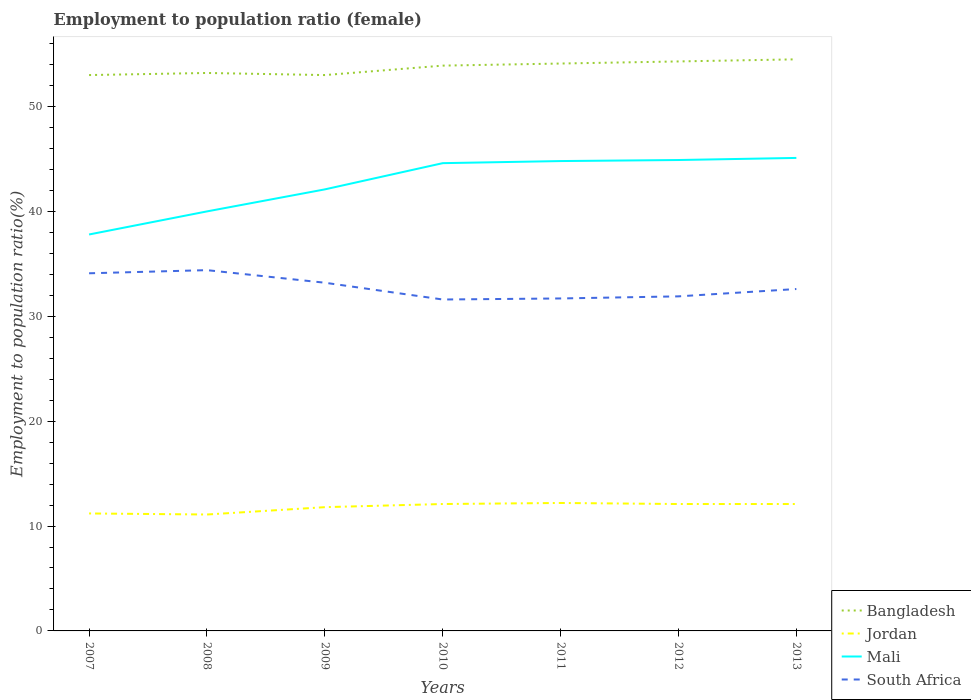Is the number of lines equal to the number of legend labels?
Provide a short and direct response. Yes. Across all years, what is the maximum employment to population ratio in Jordan?
Offer a very short reply. 11.1. What is the total employment to population ratio in Jordan in the graph?
Provide a short and direct response. -0.4. What is the difference between the highest and the second highest employment to population ratio in Jordan?
Your answer should be compact. 1.1. What is the difference between the highest and the lowest employment to population ratio in South Africa?
Offer a very short reply. 3. Are the values on the major ticks of Y-axis written in scientific E-notation?
Offer a very short reply. No. Does the graph contain any zero values?
Provide a succinct answer. No. Does the graph contain grids?
Provide a succinct answer. No. How many legend labels are there?
Give a very brief answer. 4. What is the title of the graph?
Provide a succinct answer. Employment to population ratio (female). Does "St. Vincent and the Grenadines" appear as one of the legend labels in the graph?
Make the answer very short. No. What is the label or title of the X-axis?
Give a very brief answer. Years. What is the Employment to population ratio(%) in Bangladesh in 2007?
Your response must be concise. 53. What is the Employment to population ratio(%) of Jordan in 2007?
Offer a terse response. 11.2. What is the Employment to population ratio(%) in Mali in 2007?
Provide a short and direct response. 37.8. What is the Employment to population ratio(%) in South Africa in 2007?
Your response must be concise. 34.1. What is the Employment to population ratio(%) of Bangladesh in 2008?
Offer a terse response. 53.2. What is the Employment to population ratio(%) in Jordan in 2008?
Keep it short and to the point. 11.1. What is the Employment to population ratio(%) in Mali in 2008?
Give a very brief answer. 40. What is the Employment to population ratio(%) in South Africa in 2008?
Offer a very short reply. 34.4. What is the Employment to population ratio(%) of Bangladesh in 2009?
Your answer should be compact. 53. What is the Employment to population ratio(%) in Jordan in 2009?
Your answer should be very brief. 11.8. What is the Employment to population ratio(%) in Mali in 2009?
Your answer should be compact. 42.1. What is the Employment to population ratio(%) in South Africa in 2009?
Provide a succinct answer. 33.2. What is the Employment to population ratio(%) of Bangladesh in 2010?
Give a very brief answer. 53.9. What is the Employment to population ratio(%) of Jordan in 2010?
Your answer should be compact. 12.1. What is the Employment to population ratio(%) of Mali in 2010?
Provide a succinct answer. 44.6. What is the Employment to population ratio(%) of South Africa in 2010?
Ensure brevity in your answer.  31.6. What is the Employment to population ratio(%) in Bangladesh in 2011?
Give a very brief answer. 54.1. What is the Employment to population ratio(%) in Jordan in 2011?
Provide a succinct answer. 12.2. What is the Employment to population ratio(%) in Mali in 2011?
Provide a succinct answer. 44.8. What is the Employment to population ratio(%) in South Africa in 2011?
Keep it short and to the point. 31.7. What is the Employment to population ratio(%) of Bangladesh in 2012?
Provide a succinct answer. 54.3. What is the Employment to population ratio(%) of Jordan in 2012?
Offer a terse response. 12.1. What is the Employment to population ratio(%) in Mali in 2012?
Provide a short and direct response. 44.9. What is the Employment to population ratio(%) in South Africa in 2012?
Provide a short and direct response. 31.9. What is the Employment to population ratio(%) of Bangladesh in 2013?
Offer a very short reply. 54.5. What is the Employment to population ratio(%) in Jordan in 2013?
Keep it short and to the point. 12.1. What is the Employment to population ratio(%) in Mali in 2013?
Offer a very short reply. 45.1. What is the Employment to population ratio(%) of South Africa in 2013?
Provide a short and direct response. 32.6. Across all years, what is the maximum Employment to population ratio(%) in Bangladesh?
Provide a short and direct response. 54.5. Across all years, what is the maximum Employment to population ratio(%) in Jordan?
Offer a very short reply. 12.2. Across all years, what is the maximum Employment to population ratio(%) in Mali?
Offer a very short reply. 45.1. Across all years, what is the maximum Employment to population ratio(%) of South Africa?
Give a very brief answer. 34.4. Across all years, what is the minimum Employment to population ratio(%) of Bangladesh?
Ensure brevity in your answer.  53. Across all years, what is the minimum Employment to population ratio(%) of Jordan?
Provide a short and direct response. 11.1. Across all years, what is the minimum Employment to population ratio(%) in Mali?
Your answer should be compact. 37.8. Across all years, what is the minimum Employment to population ratio(%) in South Africa?
Your response must be concise. 31.6. What is the total Employment to population ratio(%) in Bangladesh in the graph?
Your response must be concise. 376. What is the total Employment to population ratio(%) in Jordan in the graph?
Provide a succinct answer. 82.6. What is the total Employment to population ratio(%) of Mali in the graph?
Ensure brevity in your answer.  299.3. What is the total Employment to population ratio(%) in South Africa in the graph?
Your answer should be compact. 229.5. What is the difference between the Employment to population ratio(%) of Bangladesh in 2007 and that in 2008?
Provide a short and direct response. -0.2. What is the difference between the Employment to population ratio(%) of Jordan in 2007 and that in 2008?
Ensure brevity in your answer.  0.1. What is the difference between the Employment to population ratio(%) of South Africa in 2007 and that in 2008?
Provide a succinct answer. -0.3. What is the difference between the Employment to population ratio(%) in Jordan in 2007 and that in 2009?
Keep it short and to the point. -0.6. What is the difference between the Employment to population ratio(%) in South Africa in 2007 and that in 2009?
Ensure brevity in your answer.  0.9. What is the difference between the Employment to population ratio(%) of Mali in 2007 and that in 2010?
Provide a succinct answer. -6.8. What is the difference between the Employment to population ratio(%) of South Africa in 2007 and that in 2010?
Your answer should be compact. 2.5. What is the difference between the Employment to population ratio(%) of Bangladesh in 2007 and that in 2011?
Ensure brevity in your answer.  -1.1. What is the difference between the Employment to population ratio(%) of Jordan in 2007 and that in 2011?
Your answer should be very brief. -1. What is the difference between the Employment to population ratio(%) of South Africa in 2007 and that in 2011?
Your response must be concise. 2.4. What is the difference between the Employment to population ratio(%) in Bangladesh in 2007 and that in 2012?
Give a very brief answer. -1.3. What is the difference between the Employment to population ratio(%) in Jordan in 2007 and that in 2012?
Offer a very short reply. -0.9. What is the difference between the Employment to population ratio(%) in Bangladesh in 2007 and that in 2013?
Ensure brevity in your answer.  -1.5. What is the difference between the Employment to population ratio(%) in Bangladesh in 2008 and that in 2009?
Keep it short and to the point. 0.2. What is the difference between the Employment to population ratio(%) of Jordan in 2008 and that in 2009?
Provide a succinct answer. -0.7. What is the difference between the Employment to population ratio(%) in Mali in 2008 and that in 2009?
Your answer should be compact. -2.1. What is the difference between the Employment to population ratio(%) in Jordan in 2008 and that in 2010?
Your response must be concise. -1. What is the difference between the Employment to population ratio(%) in Mali in 2008 and that in 2010?
Your response must be concise. -4.6. What is the difference between the Employment to population ratio(%) of South Africa in 2008 and that in 2010?
Keep it short and to the point. 2.8. What is the difference between the Employment to population ratio(%) in Bangladesh in 2008 and that in 2011?
Ensure brevity in your answer.  -0.9. What is the difference between the Employment to population ratio(%) of Jordan in 2008 and that in 2011?
Provide a short and direct response. -1.1. What is the difference between the Employment to population ratio(%) of Mali in 2008 and that in 2011?
Provide a short and direct response. -4.8. What is the difference between the Employment to population ratio(%) in Bangladesh in 2008 and that in 2012?
Your answer should be very brief. -1.1. What is the difference between the Employment to population ratio(%) of Mali in 2008 and that in 2012?
Provide a short and direct response. -4.9. What is the difference between the Employment to population ratio(%) of Bangladesh in 2008 and that in 2013?
Your answer should be compact. -1.3. What is the difference between the Employment to population ratio(%) in Bangladesh in 2009 and that in 2010?
Offer a very short reply. -0.9. What is the difference between the Employment to population ratio(%) of Jordan in 2009 and that in 2010?
Your answer should be compact. -0.3. What is the difference between the Employment to population ratio(%) of South Africa in 2009 and that in 2010?
Provide a short and direct response. 1.6. What is the difference between the Employment to population ratio(%) in Mali in 2009 and that in 2011?
Keep it short and to the point. -2.7. What is the difference between the Employment to population ratio(%) in Bangladesh in 2009 and that in 2012?
Your answer should be compact. -1.3. What is the difference between the Employment to population ratio(%) in Jordan in 2009 and that in 2012?
Make the answer very short. -0.3. What is the difference between the Employment to population ratio(%) in Mali in 2009 and that in 2012?
Your answer should be very brief. -2.8. What is the difference between the Employment to population ratio(%) in South Africa in 2009 and that in 2012?
Give a very brief answer. 1.3. What is the difference between the Employment to population ratio(%) in Jordan in 2009 and that in 2013?
Provide a short and direct response. -0.3. What is the difference between the Employment to population ratio(%) in Mali in 2009 and that in 2013?
Make the answer very short. -3. What is the difference between the Employment to population ratio(%) in Bangladesh in 2010 and that in 2011?
Your answer should be very brief. -0.2. What is the difference between the Employment to population ratio(%) of Jordan in 2010 and that in 2011?
Provide a succinct answer. -0.1. What is the difference between the Employment to population ratio(%) in South Africa in 2010 and that in 2011?
Keep it short and to the point. -0.1. What is the difference between the Employment to population ratio(%) of Bangladesh in 2010 and that in 2012?
Your answer should be compact. -0.4. What is the difference between the Employment to population ratio(%) in Jordan in 2010 and that in 2012?
Your answer should be very brief. 0. What is the difference between the Employment to population ratio(%) in South Africa in 2010 and that in 2012?
Make the answer very short. -0.3. What is the difference between the Employment to population ratio(%) of Jordan in 2010 and that in 2013?
Provide a short and direct response. 0. What is the difference between the Employment to population ratio(%) of Mali in 2010 and that in 2013?
Give a very brief answer. -0.5. What is the difference between the Employment to population ratio(%) of South Africa in 2010 and that in 2013?
Ensure brevity in your answer.  -1. What is the difference between the Employment to population ratio(%) in Bangladesh in 2011 and that in 2012?
Give a very brief answer. -0.2. What is the difference between the Employment to population ratio(%) in Mali in 2011 and that in 2012?
Make the answer very short. -0.1. What is the difference between the Employment to population ratio(%) in South Africa in 2011 and that in 2012?
Offer a terse response. -0.2. What is the difference between the Employment to population ratio(%) of Jordan in 2012 and that in 2013?
Keep it short and to the point. 0. What is the difference between the Employment to population ratio(%) in Bangladesh in 2007 and the Employment to population ratio(%) in Jordan in 2008?
Ensure brevity in your answer.  41.9. What is the difference between the Employment to population ratio(%) in Bangladesh in 2007 and the Employment to population ratio(%) in South Africa in 2008?
Give a very brief answer. 18.6. What is the difference between the Employment to population ratio(%) in Jordan in 2007 and the Employment to population ratio(%) in Mali in 2008?
Your answer should be very brief. -28.8. What is the difference between the Employment to population ratio(%) of Jordan in 2007 and the Employment to population ratio(%) of South Africa in 2008?
Keep it short and to the point. -23.2. What is the difference between the Employment to population ratio(%) of Bangladesh in 2007 and the Employment to population ratio(%) of Jordan in 2009?
Offer a very short reply. 41.2. What is the difference between the Employment to population ratio(%) of Bangladesh in 2007 and the Employment to population ratio(%) of South Africa in 2009?
Provide a short and direct response. 19.8. What is the difference between the Employment to population ratio(%) of Jordan in 2007 and the Employment to population ratio(%) of Mali in 2009?
Provide a succinct answer. -30.9. What is the difference between the Employment to population ratio(%) in Bangladesh in 2007 and the Employment to population ratio(%) in Jordan in 2010?
Make the answer very short. 40.9. What is the difference between the Employment to population ratio(%) of Bangladesh in 2007 and the Employment to population ratio(%) of South Africa in 2010?
Your answer should be very brief. 21.4. What is the difference between the Employment to population ratio(%) in Jordan in 2007 and the Employment to population ratio(%) in Mali in 2010?
Provide a short and direct response. -33.4. What is the difference between the Employment to population ratio(%) in Jordan in 2007 and the Employment to population ratio(%) in South Africa in 2010?
Provide a succinct answer. -20.4. What is the difference between the Employment to population ratio(%) in Mali in 2007 and the Employment to population ratio(%) in South Africa in 2010?
Keep it short and to the point. 6.2. What is the difference between the Employment to population ratio(%) in Bangladesh in 2007 and the Employment to population ratio(%) in Jordan in 2011?
Provide a succinct answer. 40.8. What is the difference between the Employment to population ratio(%) in Bangladesh in 2007 and the Employment to population ratio(%) in Mali in 2011?
Keep it short and to the point. 8.2. What is the difference between the Employment to population ratio(%) in Bangladesh in 2007 and the Employment to population ratio(%) in South Africa in 2011?
Give a very brief answer. 21.3. What is the difference between the Employment to population ratio(%) in Jordan in 2007 and the Employment to population ratio(%) in Mali in 2011?
Keep it short and to the point. -33.6. What is the difference between the Employment to population ratio(%) of Jordan in 2007 and the Employment to population ratio(%) of South Africa in 2011?
Ensure brevity in your answer.  -20.5. What is the difference between the Employment to population ratio(%) in Mali in 2007 and the Employment to population ratio(%) in South Africa in 2011?
Provide a succinct answer. 6.1. What is the difference between the Employment to population ratio(%) in Bangladesh in 2007 and the Employment to population ratio(%) in Jordan in 2012?
Your response must be concise. 40.9. What is the difference between the Employment to population ratio(%) in Bangladesh in 2007 and the Employment to population ratio(%) in Mali in 2012?
Give a very brief answer. 8.1. What is the difference between the Employment to population ratio(%) of Bangladesh in 2007 and the Employment to population ratio(%) of South Africa in 2012?
Give a very brief answer. 21.1. What is the difference between the Employment to population ratio(%) of Jordan in 2007 and the Employment to population ratio(%) of Mali in 2012?
Ensure brevity in your answer.  -33.7. What is the difference between the Employment to population ratio(%) of Jordan in 2007 and the Employment to population ratio(%) of South Africa in 2012?
Give a very brief answer. -20.7. What is the difference between the Employment to population ratio(%) in Mali in 2007 and the Employment to population ratio(%) in South Africa in 2012?
Your response must be concise. 5.9. What is the difference between the Employment to population ratio(%) of Bangladesh in 2007 and the Employment to population ratio(%) of Jordan in 2013?
Offer a very short reply. 40.9. What is the difference between the Employment to population ratio(%) in Bangladesh in 2007 and the Employment to population ratio(%) in South Africa in 2013?
Your answer should be compact. 20.4. What is the difference between the Employment to population ratio(%) in Jordan in 2007 and the Employment to population ratio(%) in Mali in 2013?
Offer a very short reply. -33.9. What is the difference between the Employment to population ratio(%) in Jordan in 2007 and the Employment to population ratio(%) in South Africa in 2013?
Keep it short and to the point. -21.4. What is the difference between the Employment to population ratio(%) of Bangladesh in 2008 and the Employment to population ratio(%) of Jordan in 2009?
Offer a very short reply. 41.4. What is the difference between the Employment to population ratio(%) of Bangladesh in 2008 and the Employment to population ratio(%) of Mali in 2009?
Make the answer very short. 11.1. What is the difference between the Employment to population ratio(%) in Bangladesh in 2008 and the Employment to population ratio(%) in South Africa in 2009?
Offer a terse response. 20. What is the difference between the Employment to population ratio(%) of Jordan in 2008 and the Employment to population ratio(%) of Mali in 2009?
Your answer should be very brief. -31. What is the difference between the Employment to population ratio(%) of Jordan in 2008 and the Employment to population ratio(%) of South Africa in 2009?
Your answer should be very brief. -22.1. What is the difference between the Employment to population ratio(%) of Mali in 2008 and the Employment to population ratio(%) of South Africa in 2009?
Ensure brevity in your answer.  6.8. What is the difference between the Employment to population ratio(%) of Bangladesh in 2008 and the Employment to population ratio(%) of Jordan in 2010?
Offer a terse response. 41.1. What is the difference between the Employment to population ratio(%) of Bangladesh in 2008 and the Employment to population ratio(%) of South Africa in 2010?
Make the answer very short. 21.6. What is the difference between the Employment to population ratio(%) of Jordan in 2008 and the Employment to population ratio(%) of Mali in 2010?
Make the answer very short. -33.5. What is the difference between the Employment to population ratio(%) of Jordan in 2008 and the Employment to population ratio(%) of South Africa in 2010?
Give a very brief answer. -20.5. What is the difference between the Employment to population ratio(%) of Mali in 2008 and the Employment to population ratio(%) of South Africa in 2010?
Your answer should be compact. 8.4. What is the difference between the Employment to population ratio(%) in Bangladesh in 2008 and the Employment to population ratio(%) in Jordan in 2011?
Provide a succinct answer. 41. What is the difference between the Employment to population ratio(%) in Bangladesh in 2008 and the Employment to population ratio(%) in Mali in 2011?
Your response must be concise. 8.4. What is the difference between the Employment to population ratio(%) in Bangladesh in 2008 and the Employment to population ratio(%) in South Africa in 2011?
Your answer should be compact. 21.5. What is the difference between the Employment to population ratio(%) in Jordan in 2008 and the Employment to population ratio(%) in Mali in 2011?
Provide a short and direct response. -33.7. What is the difference between the Employment to population ratio(%) in Jordan in 2008 and the Employment to population ratio(%) in South Africa in 2011?
Ensure brevity in your answer.  -20.6. What is the difference between the Employment to population ratio(%) in Mali in 2008 and the Employment to population ratio(%) in South Africa in 2011?
Give a very brief answer. 8.3. What is the difference between the Employment to population ratio(%) of Bangladesh in 2008 and the Employment to population ratio(%) of Jordan in 2012?
Your response must be concise. 41.1. What is the difference between the Employment to population ratio(%) of Bangladesh in 2008 and the Employment to population ratio(%) of South Africa in 2012?
Provide a succinct answer. 21.3. What is the difference between the Employment to population ratio(%) in Jordan in 2008 and the Employment to population ratio(%) in Mali in 2012?
Provide a short and direct response. -33.8. What is the difference between the Employment to population ratio(%) in Jordan in 2008 and the Employment to population ratio(%) in South Africa in 2012?
Make the answer very short. -20.8. What is the difference between the Employment to population ratio(%) in Mali in 2008 and the Employment to population ratio(%) in South Africa in 2012?
Your answer should be compact. 8.1. What is the difference between the Employment to population ratio(%) in Bangladesh in 2008 and the Employment to population ratio(%) in Jordan in 2013?
Offer a terse response. 41.1. What is the difference between the Employment to population ratio(%) of Bangladesh in 2008 and the Employment to population ratio(%) of South Africa in 2013?
Provide a succinct answer. 20.6. What is the difference between the Employment to population ratio(%) in Jordan in 2008 and the Employment to population ratio(%) in Mali in 2013?
Your answer should be compact. -34. What is the difference between the Employment to population ratio(%) in Jordan in 2008 and the Employment to population ratio(%) in South Africa in 2013?
Provide a short and direct response. -21.5. What is the difference between the Employment to population ratio(%) of Mali in 2008 and the Employment to population ratio(%) of South Africa in 2013?
Offer a terse response. 7.4. What is the difference between the Employment to population ratio(%) of Bangladesh in 2009 and the Employment to population ratio(%) of Jordan in 2010?
Give a very brief answer. 40.9. What is the difference between the Employment to population ratio(%) in Bangladesh in 2009 and the Employment to population ratio(%) in Mali in 2010?
Provide a succinct answer. 8.4. What is the difference between the Employment to population ratio(%) in Bangladesh in 2009 and the Employment to population ratio(%) in South Africa in 2010?
Make the answer very short. 21.4. What is the difference between the Employment to population ratio(%) of Jordan in 2009 and the Employment to population ratio(%) of Mali in 2010?
Give a very brief answer. -32.8. What is the difference between the Employment to population ratio(%) in Jordan in 2009 and the Employment to population ratio(%) in South Africa in 2010?
Offer a terse response. -19.8. What is the difference between the Employment to population ratio(%) of Bangladesh in 2009 and the Employment to population ratio(%) of Jordan in 2011?
Ensure brevity in your answer.  40.8. What is the difference between the Employment to population ratio(%) of Bangladesh in 2009 and the Employment to population ratio(%) of South Africa in 2011?
Give a very brief answer. 21.3. What is the difference between the Employment to population ratio(%) of Jordan in 2009 and the Employment to population ratio(%) of Mali in 2011?
Offer a terse response. -33. What is the difference between the Employment to population ratio(%) of Jordan in 2009 and the Employment to population ratio(%) of South Africa in 2011?
Provide a succinct answer. -19.9. What is the difference between the Employment to population ratio(%) of Bangladesh in 2009 and the Employment to population ratio(%) of Jordan in 2012?
Give a very brief answer. 40.9. What is the difference between the Employment to population ratio(%) in Bangladesh in 2009 and the Employment to population ratio(%) in Mali in 2012?
Offer a terse response. 8.1. What is the difference between the Employment to population ratio(%) of Bangladesh in 2009 and the Employment to population ratio(%) of South Africa in 2012?
Give a very brief answer. 21.1. What is the difference between the Employment to population ratio(%) in Jordan in 2009 and the Employment to population ratio(%) in Mali in 2012?
Your answer should be compact. -33.1. What is the difference between the Employment to population ratio(%) in Jordan in 2009 and the Employment to population ratio(%) in South Africa in 2012?
Provide a succinct answer. -20.1. What is the difference between the Employment to population ratio(%) of Bangladesh in 2009 and the Employment to population ratio(%) of Jordan in 2013?
Provide a short and direct response. 40.9. What is the difference between the Employment to population ratio(%) in Bangladesh in 2009 and the Employment to population ratio(%) in Mali in 2013?
Ensure brevity in your answer.  7.9. What is the difference between the Employment to population ratio(%) in Bangladesh in 2009 and the Employment to population ratio(%) in South Africa in 2013?
Provide a succinct answer. 20.4. What is the difference between the Employment to population ratio(%) in Jordan in 2009 and the Employment to population ratio(%) in Mali in 2013?
Your answer should be very brief. -33.3. What is the difference between the Employment to population ratio(%) of Jordan in 2009 and the Employment to population ratio(%) of South Africa in 2013?
Your answer should be compact. -20.8. What is the difference between the Employment to population ratio(%) in Bangladesh in 2010 and the Employment to population ratio(%) in Jordan in 2011?
Provide a short and direct response. 41.7. What is the difference between the Employment to population ratio(%) of Bangladesh in 2010 and the Employment to population ratio(%) of Mali in 2011?
Your response must be concise. 9.1. What is the difference between the Employment to population ratio(%) of Bangladesh in 2010 and the Employment to population ratio(%) of South Africa in 2011?
Provide a short and direct response. 22.2. What is the difference between the Employment to population ratio(%) of Jordan in 2010 and the Employment to population ratio(%) of Mali in 2011?
Make the answer very short. -32.7. What is the difference between the Employment to population ratio(%) of Jordan in 2010 and the Employment to population ratio(%) of South Africa in 2011?
Keep it short and to the point. -19.6. What is the difference between the Employment to population ratio(%) in Mali in 2010 and the Employment to population ratio(%) in South Africa in 2011?
Your response must be concise. 12.9. What is the difference between the Employment to population ratio(%) of Bangladesh in 2010 and the Employment to population ratio(%) of Jordan in 2012?
Make the answer very short. 41.8. What is the difference between the Employment to population ratio(%) in Bangladesh in 2010 and the Employment to population ratio(%) in Mali in 2012?
Provide a short and direct response. 9. What is the difference between the Employment to population ratio(%) in Bangladesh in 2010 and the Employment to population ratio(%) in South Africa in 2012?
Provide a succinct answer. 22. What is the difference between the Employment to population ratio(%) of Jordan in 2010 and the Employment to population ratio(%) of Mali in 2012?
Your answer should be compact. -32.8. What is the difference between the Employment to population ratio(%) of Jordan in 2010 and the Employment to population ratio(%) of South Africa in 2012?
Make the answer very short. -19.8. What is the difference between the Employment to population ratio(%) in Mali in 2010 and the Employment to population ratio(%) in South Africa in 2012?
Offer a very short reply. 12.7. What is the difference between the Employment to population ratio(%) in Bangladesh in 2010 and the Employment to population ratio(%) in Jordan in 2013?
Ensure brevity in your answer.  41.8. What is the difference between the Employment to population ratio(%) in Bangladesh in 2010 and the Employment to population ratio(%) in Mali in 2013?
Your answer should be compact. 8.8. What is the difference between the Employment to population ratio(%) in Bangladesh in 2010 and the Employment to population ratio(%) in South Africa in 2013?
Your answer should be compact. 21.3. What is the difference between the Employment to population ratio(%) of Jordan in 2010 and the Employment to population ratio(%) of Mali in 2013?
Make the answer very short. -33. What is the difference between the Employment to population ratio(%) in Jordan in 2010 and the Employment to population ratio(%) in South Africa in 2013?
Make the answer very short. -20.5. What is the difference between the Employment to population ratio(%) of Mali in 2010 and the Employment to population ratio(%) of South Africa in 2013?
Your response must be concise. 12. What is the difference between the Employment to population ratio(%) of Bangladesh in 2011 and the Employment to population ratio(%) of Jordan in 2012?
Your answer should be compact. 42. What is the difference between the Employment to population ratio(%) in Bangladesh in 2011 and the Employment to population ratio(%) in South Africa in 2012?
Your answer should be very brief. 22.2. What is the difference between the Employment to population ratio(%) of Jordan in 2011 and the Employment to population ratio(%) of Mali in 2012?
Your response must be concise. -32.7. What is the difference between the Employment to population ratio(%) of Jordan in 2011 and the Employment to population ratio(%) of South Africa in 2012?
Offer a terse response. -19.7. What is the difference between the Employment to population ratio(%) of Jordan in 2011 and the Employment to population ratio(%) of Mali in 2013?
Offer a very short reply. -32.9. What is the difference between the Employment to population ratio(%) of Jordan in 2011 and the Employment to population ratio(%) of South Africa in 2013?
Offer a terse response. -20.4. What is the difference between the Employment to population ratio(%) in Mali in 2011 and the Employment to population ratio(%) in South Africa in 2013?
Your response must be concise. 12.2. What is the difference between the Employment to population ratio(%) in Bangladesh in 2012 and the Employment to population ratio(%) in Jordan in 2013?
Provide a succinct answer. 42.2. What is the difference between the Employment to population ratio(%) in Bangladesh in 2012 and the Employment to population ratio(%) in South Africa in 2013?
Make the answer very short. 21.7. What is the difference between the Employment to population ratio(%) in Jordan in 2012 and the Employment to population ratio(%) in Mali in 2013?
Keep it short and to the point. -33. What is the difference between the Employment to population ratio(%) of Jordan in 2012 and the Employment to population ratio(%) of South Africa in 2013?
Make the answer very short. -20.5. What is the difference between the Employment to population ratio(%) in Mali in 2012 and the Employment to population ratio(%) in South Africa in 2013?
Your answer should be compact. 12.3. What is the average Employment to population ratio(%) of Bangladesh per year?
Offer a very short reply. 53.71. What is the average Employment to population ratio(%) of Jordan per year?
Give a very brief answer. 11.8. What is the average Employment to population ratio(%) of Mali per year?
Keep it short and to the point. 42.76. What is the average Employment to population ratio(%) in South Africa per year?
Give a very brief answer. 32.79. In the year 2007, what is the difference between the Employment to population ratio(%) of Bangladesh and Employment to population ratio(%) of Jordan?
Keep it short and to the point. 41.8. In the year 2007, what is the difference between the Employment to population ratio(%) in Bangladesh and Employment to population ratio(%) in South Africa?
Offer a very short reply. 18.9. In the year 2007, what is the difference between the Employment to population ratio(%) in Jordan and Employment to population ratio(%) in Mali?
Your answer should be compact. -26.6. In the year 2007, what is the difference between the Employment to population ratio(%) in Jordan and Employment to population ratio(%) in South Africa?
Your answer should be very brief. -22.9. In the year 2008, what is the difference between the Employment to population ratio(%) in Bangladesh and Employment to population ratio(%) in Jordan?
Make the answer very short. 42.1. In the year 2008, what is the difference between the Employment to population ratio(%) in Bangladesh and Employment to population ratio(%) in South Africa?
Your response must be concise. 18.8. In the year 2008, what is the difference between the Employment to population ratio(%) in Jordan and Employment to population ratio(%) in Mali?
Your answer should be very brief. -28.9. In the year 2008, what is the difference between the Employment to population ratio(%) of Jordan and Employment to population ratio(%) of South Africa?
Ensure brevity in your answer.  -23.3. In the year 2008, what is the difference between the Employment to population ratio(%) of Mali and Employment to population ratio(%) of South Africa?
Offer a terse response. 5.6. In the year 2009, what is the difference between the Employment to population ratio(%) of Bangladesh and Employment to population ratio(%) of Jordan?
Make the answer very short. 41.2. In the year 2009, what is the difference between the Employment to population ratio(%) of Bangladesh and Employment to population ratio(%) of Mali?
Provide a short and direct response. 10.9. In the year 2009, what is the difference between the Employment to population ratio(%) in Bangladesh and Employment to population ratio(%) in South Africa?
Make the answer very short. 19.8. In the year 2009, what is the difference between the Employment to population ratio(%) of Jordan and Employment to population ratio(%) of Mali?
Ensure brevity in your answer.  -30.3. In the year 2009, what is the difference between the Employment to population ratio(%) in Jordan and Employment to population ratio(%) in South Africa?
Make the answer very short. -21.4. In the year 2009, what is the difference between the Employment to population ratio(%) of Mali and Employment to population ratio(%) of South Africa?
Give a very brief answer. 8.9. In the year 2010, what is the difference between the Employment to population ratio(%) of Bangladesh and Employment to population ratio(%) of Jordan?
Make the answer very short. 41.8. In the year 2010, what is the difference between the Employment to population ratio(%) in Bangladesh and Employment to population ratio(%) in South Africa?
Ensure brevity in your answer.  22.3. In the year 2010, what is the difference between the Employment to population ratio(%) of Jordan and Employment to population ratio(%) of Mali?
Provide a short and direct response. -32.5. In the year 2010, what is the difference between the Employment to population ratio(%) of Jordan and Employment to population ratio(%) of South Africa?
Keep it short and to the point. -19.5. In the year 2011, what is the difference between the Employment to population ratio(%) in Bangladesh and Employment to population ratio(%) in Jordan?
Make the answer very short. 41.9. In the year 2011, what is the difference between the Employment to population ratio(%) of Bangladesh and Employment to population ratio(%) of South Africa?
Offer a terse response. 22.4. In the year 2011, what is the difference between the Employment to population ratio(%) of Jordan and Employment to population ratio(%) of Mali?
Provide a succinct answer. -32.6. In the year 2011, what is the difference between the Employment to population ratio(%) in Jordan and Employment to population ratio(%) in South Africa?
Your response must be concise. -19.5. In the year 2012, what is the difference between the Employment to population ratio(%) of Bangladesh and Employment to population ratio(%) of Jordan?
Offer a terse response. 42.2. In the year 2012, what is the difference between the Employment to population ratio(%) in Bangladesh and Employment to population ratio(%) in South Africa?
Give a very brief answer. 22.4. In the year 2012, what is the difference between the Employment to population ratio(%) of Jordan and Employment to population ratio(%) of Mali?
Offer a very short reply. -32.8. In the year 2012, what is the difference between the Employment to population ratio(%) in Jordan and Employment to population ratio(%) in South Africa?
Make the answer very short. -19.8. In the year 2013, what is the difference between the Employment to population ratio(%) of Bangladesh and Employment to population ratio(%) of Jordan?
Provide a short and direct response. 42.4. In the year 2013, what is the difference between the Employment to population ratio(%) of Bangladesh and Employment to population ratio(%) of Mali?
Make the answer very short. 9.4. In the year 2013, what is the difference between the Employment to population ratio(%) in Bangladesh and Employment to population ratio(%) in South Africa?
Give a very brief answer. 21.9. In the year 2013, what is the difference between the Employment to population ratio(%) of Jordan and Employment to population ratio(%) of Mali?
Your answer should be compact. -33. In the year 2013, what is the difference between the Employment to population ratio(%) in Jordan and Employment to population ratio(%) in South Africa?
Your answer should be compact. -20.5. What is the ratio of the Employment to population ratio(%) in Jordan in 2007 to that in 2008?
Your answer should be very brief. 1.01. What is the ratio of the Employment to population ratio(%) in Mali in 2007 to that in 2008?
Ensure brevity in your answer.  0.94. What is the ratio of the Employment to population ratio(%) of Bangladesh in 2007 to that in 2009?
Your response must be concise. 1. What is the ratio of the Employment to population ratio(%) of Jordan in 2007 to that in 2009?
Keep it short and to the point. 0.95. What is the ratio of the Employment to population ratio(%) in Mali in 2007 to that in 2009?
Ensure brevity in your answer.  0.9. What is the ratio of the Employment to population ratio(%) of South Africa in 2007 to that in 2009?
Provide a succinct answer. 1.03. What is the ratio of the Employment to population ratio(%) in Bangladesh in 2007 to that in 2010?
Your answer should be compact. 0.98. What is the ratio of the Employment to population ratio(%) of Jordan in 2007 to that in 2010?
Offer a very short reply. 0.93. What is the ratio of the Employment to population ratio(%) of Mali in 2007 to that in 2010?
Give a very brief answer. 0.85. What is the ratio of the Employment to population ratio(%) in South Africa in 2007 to that in 2010?
Your response must be concise. 1.08. What is the ratio of the Employment to population ratio(%) in Bangladesh in 2007 to that in 2011?
Offer a terse response. 0.98. What is the ratio of the Employment to population ratio(%) of Jordan in 2007 to that in 2011?
Keep it short and to the point. 0.92. What is the ratio of the Employment to population ratio(%) in Mali in 2007 to that in 2011?
Provide a short and direct response. 0.84. What is the ratio of the Employment to population ratio(%) in South Africa in 2007 to that in 2011?
Give a very brief answer. 1.08. What is the ratio of the Employment to population ratio(%) in Bangladesh in 2007 to that in 2012?
Your response must be concise. 0.98. What is the ratio of the Employment to population ratio(%) of Jordan in 2007 to that in 2012?
Offer a terse response. 0.93. What is the ratio of the Employment to population ratio(%) of Mali in 2007 to that in 2012?
Make the answer very short. 0.84. What is the ratio of the Employment to population ratio(%) in South Africa in 2007 to that in 2012?
Offer a terse response. 1.07. What is the ratio of the Employment to population ratio(%) in Bangladesh in 2007 to that in 2013?
Provide a short and direct response. 0.97. What is the ratio of the Employment to population ratio(%) in Jordan in 2007 to that in 2013?
Your answer should be compact. 0.93. What is the ratio of the Employment to population ratio(%) of Mali in 2007 to that in 2013?
Your answer should be very brief. 0.84. What is the ratio of the Employment to population ratio(%) of South Africa in 2007 to that in 2013?
Offer a terse response. 1.05. What is the ratio of the Employment to population ratio(%) of Bangladesh in 2008 to that in 2009?
Your answer should be compact. 1. What is the ratio of the Employment to population ratio(%) in Jordan in 2008 to that in 2009?
Your answer should be very brief. 0.94. What is the ratio of the Employment to population ratio(%) in Mali in 2008 to that in 2009?
Ensure brevity in your answer.  0.95. What is the ratio of the Employment to population ratio(%) in South Africa in 2008 to that in 2009?
Give a very brief answer. 1.04. What is the ratio of the Employment to population ratio(%) in Bangladesh in 2008 to that in 2010?
Give a very brief answer. 0.99. What is the ratio of the Employment to population ratio(%) of Jordan in 2008 to that in 2010?
Keep it short and to the point. 0.92. What is the ratio of the Employment to population ratio(%) in Mali in 2008 to that in 2010?
Make the answer very short. 0.9. What is the ratio of the Employment to population ratio(%) of South Africa in 2008 to that in 2010?
Provide a succinct answer. 1.09. What is the ratio of the Employment to population ratio(%) of Bangladesh in 2008 to that in 2011?
Provide a succinct answer. 0.98. What is the ratio of the Employment to population ratio(%) of Jordan in 2008 to that in 2011?
Your response must be concise. 0.91. What is the ratio of the Employment to population ratio(%) in Mali in 2008 to that in 2011?
Ensure brevity in your answer.  0.89. What is the ratio of the Employment to population ratio(%) in South Africa in 2008 to that in 2011?
Offer a terse response. 1.09. What is the ratio of the Employment to population ratio(%) in Bangladesh in 2008 to that in 2012?
Provide a succinct answer. 0.98. What is the ratio of the Employment to population ratio(%) in Jordan in 2008 to that in 2012?
Offer a terse response. 0.92. What is the ratio of the Employment to population ratio(%) in Mali in 2008 to that in 2012?
Your response must be concise. 0.89. What is the ratio of the Employment to population ratio(%) of South Africa in 2008 to that in 2012?
Offer a very short reply. 1.08. What is the ratio of the Employment to population ratio(%) in Bangladesh in 2008 to that in 2013?
Your response must be concise. 0.98. What is the ratio of the Employment to population ratio(%) of Jordan in 2008 to that in 2013?
Give a very brief answer. 0.92. What is the ratio of the Employment to population ratio(%) of Mali in 2008 to that in 2013?
Give a very brief answer. 0.89. What is the ratio of the Employment to population ratio(%) in South Africa in 2008 to that in 2013?
Make the answer very short. 1.06. What is the ratio of the Employment to population ratio(%) in Bangladesh in 2009 to that in 2010?
Ensure brevity in your answer.  0.98. What is the ratio of the Employment to population ratio(%) in Jordan in 2009 to that in 2010?
Provide a succinct answer. 0.98. What is the ratio of the Employment to population ratio(%) in Mali in 2009 to that in 2010?
Keep it short and to the point. 0.94. What is the ratio of the Employment to population ratio(%) in South Africa in 2009 to that in 2010?
Your answer should be very brief. 1.05. What is the ratio of the Employment to population ratio(%) of Bangladesh in 2009 to that in 2011?
Your answer should be very brief. 0.98. What is the ratio of the Employment to population ratio(%) of Jordan in 2009 to that in 2011?
Provide a short and direct response. 0.97. What is the ratio of the Employment to population ratio(%) in Mali in 2009 to that in 2011?
Offer a terse response. 0.94. What is the ratio of the Employment to population ratio(%) in South Africa in 2009 to that in 2011?
Offer a terse response. 1.05. What is the ratio of the Employment to population ratio(%) in Bangladesh in 2009 to that in 2012?
Your answer should be compact. 0.98. What is the ratio of the Employment to population ratio(%) in Jordan in 2009 to that in 2012?
Offer a very short reply. 0.98. What is the ratio of the Employment to population ratio(%) of Mali in 2009 to that in 2012?
Provide a short and direct response. 0.94. What is the ratio of the Employment to population ratio(%) in South Africa in 2009 to that in 2012?
Provide a short and direct response. 1.04. What is the ratio of the Employment to population ratio(%) of Bangladesh in 2009 to that in 2013?
Give a very brief answer. 0.97. What is the ratio of the Employment to population ratio(%) in Jordan in 2009 to that in 2013?
Offer a very short reply. 0.98. What is the ratio of the Employment to population ratio(%) of Mali in 2009 to that in 2013?
Ensure brevity in your answer.  0.93. What is the ratio of the Employment to population ratio(%) of South Africa in 2009 to that in 2013?
Your answer should be compact. 1.02. What is the ratio of the Employment to population ratio(%) of Bangladesh in 2010 to that in 2011?
Your answer should be very brief. 1. What is the ratio of the Employment to population ratio(%) of Jordan in 2010 to that in 2011?
Offer a very short reply. 0.99. What is the ratio of the Employment to population ratio(%) in Mali in 2010 to that in 2012?
Give a very brief answer. 0.99. What is the ratio of the Employment to population ratio(%) of South Africa in 2010 to that in 2012?
Offer a very short reply. 0.99. What is the ratio of the Employment to population ratio(%) in Mali in 2010 to that in 2013?
Your answer should be very brief. 0.99. What is the ratio of the Employment to population ratio(%) in South Africa in 2010 to that in 2013?
Your answer should be very brief. 0.97. What is the ratio of the Employment to population ratio(%) of Jordan in 2011 to that in 2012?
Ensure brevity in your answer.  1.01. What is the ratio of the Employment to population ratio(%) of Mali in 2011 to that in 2012?
Give a very brief answer. 1. What is the ratio of the Employment to population ratio(%) in South Africa in 2011 to that in 2012?
Give a very brief answer. 0.99. What is the ratio of the Employment to population ratio(%) of Bangladesh in 2011 to that in 2013?
Give a very brief answer. 0.99. What is the ratio of the Employment to population ratio(%) in Jordan in 2011 to that in 2013?
Your response must be concise. 1.01. What is the ratio of the Employment to population ratio(%) of South Africa in 2011 to that in 2013?
Keep it short and to the point. 0.97. What is the ratio of the Employment to population ratio(%) of Bangladesh in 2012 to that in 2013?
Provide a short and direct response. 1. What is the ratio of the Employment to population ratio(%) in Jordan in 2012 to that in 2013?
Make the answer very short. 1. What is the ratio of the Employment to population ratio(%) of Mali in 2012 to that in 2013?
Your answer should be compact. 1. What is the ratio of the Employment to population ratio(%) of South Africa in 2012 to that in 2013?
Provide a succinct answer. 0.98. What is the difference between the highest and the second highest Employment to population ratio(%) of Mali?
Offer a very short reply. 0.2. What is the difference between the highest and the second highest Employment to population ratio(%) of South Africa?
Offer a terse response. 0.3. What is the difference between the highest and the lowest Employment to population ratio(%) in Bangladesh?
Offer a very short reply. 1.5. What is the difference between the highest and the lowest Employment to population ratio(%) of Jordan?
Make the answer very short. 1.1. What is the difference between the highest and the lowest Employment to population ratio(%) of Mali?
Offer a terse response. 7.3. 